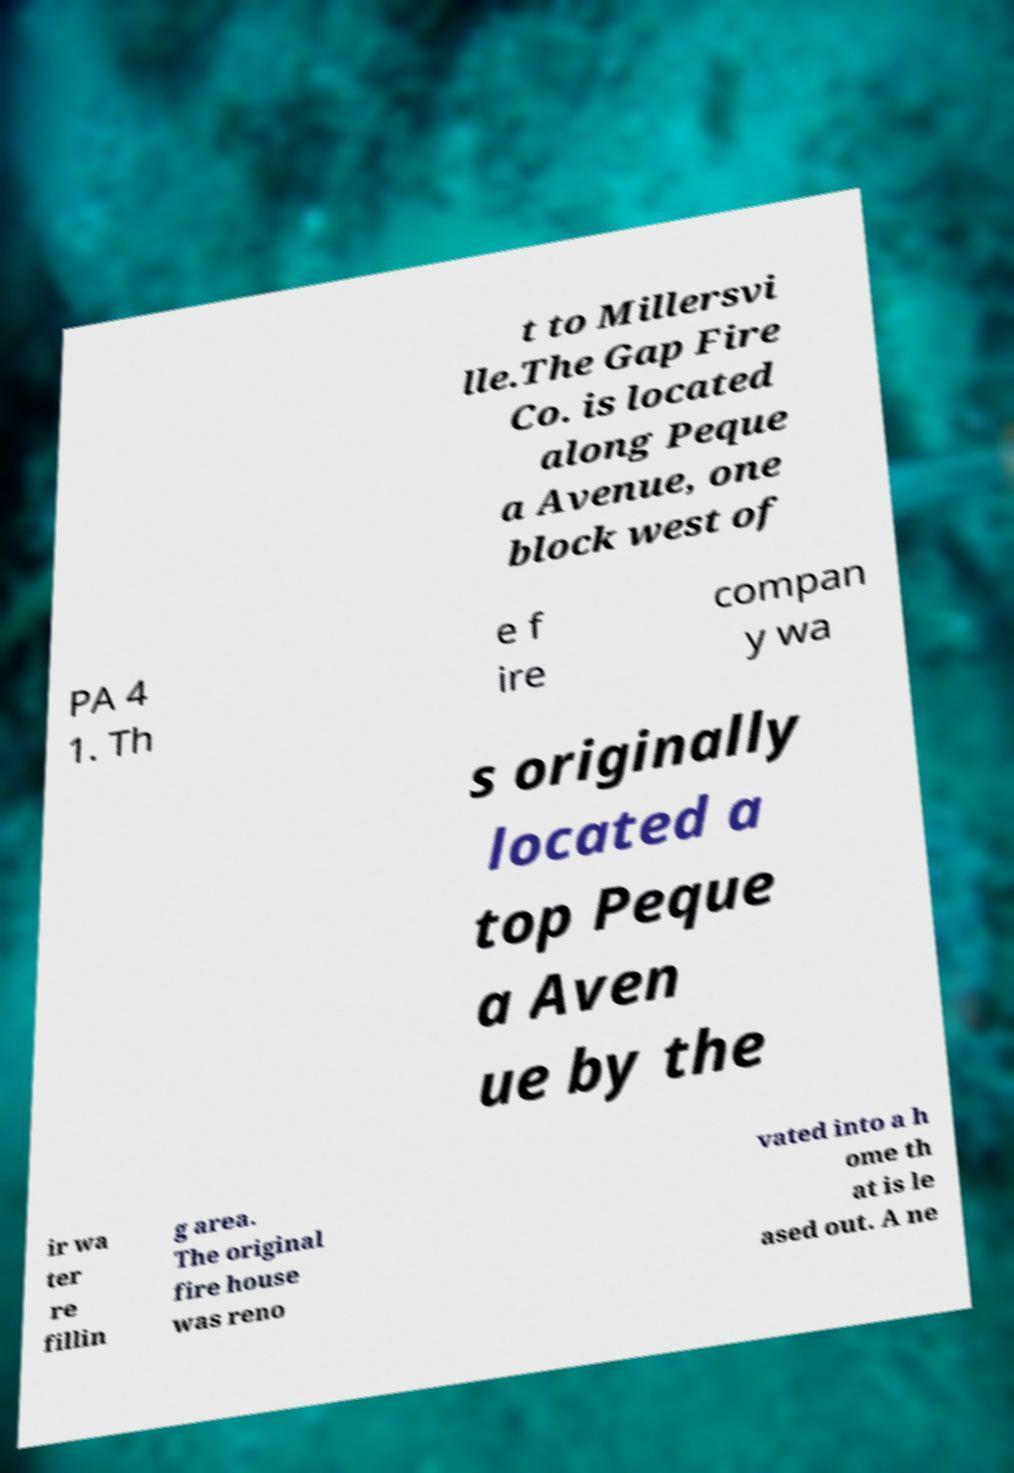Please read and relay the text visible in this image. What does it say? t to Millersvi lle.The Gap Fire Co. is located along Peque a Avenue, one block west of PA 4 1. Th e f ire compan y wa s originally located a top Peque a Aven ue by the ir wa ter re fillin g area. The original fire house was reno vated into a h ome th at is le ased out. A ne 